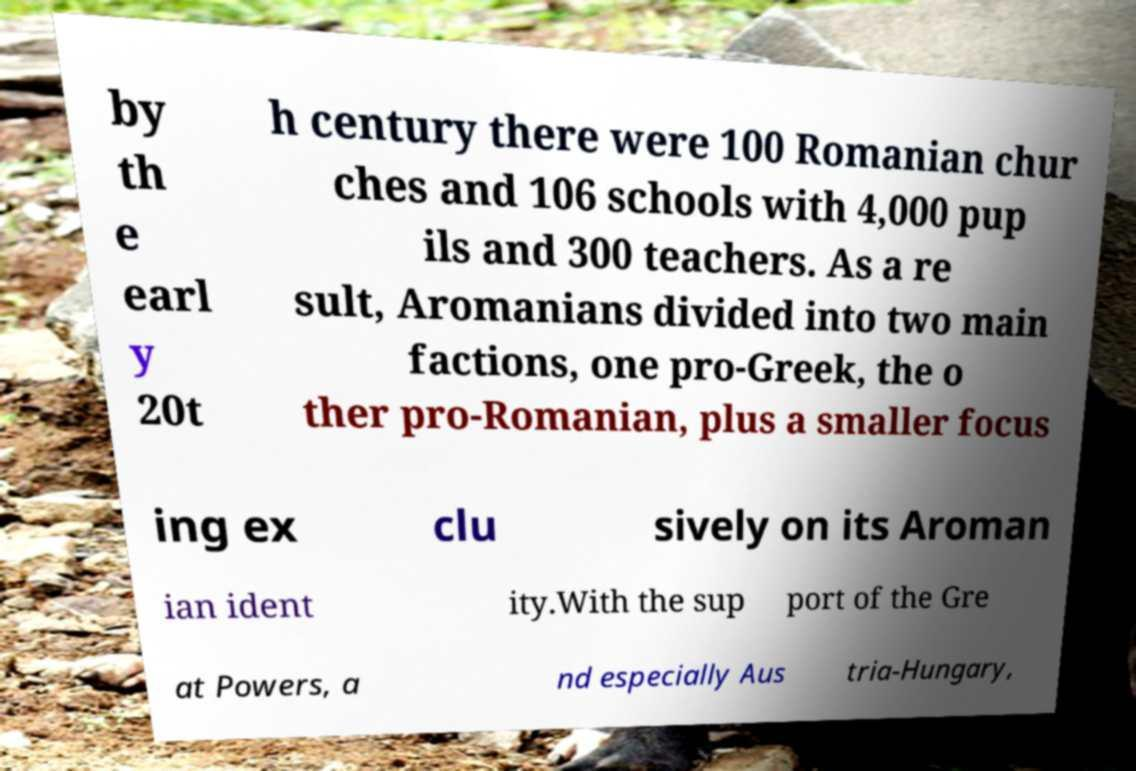There's text embedded in this image that I need extracted. Can you transcribe it verbatim? by th e earl y 20t h century there were 100 Romanian chur ches and 106 schools with 4,000 pup ils and 300 teachers. As a re sult, Aromanians divided into two main factions, one pro-Greek, the o ther pro-Romanian, plus a smaller focus ing ex clu sively on its Aroman ian ident ity.With the sup port of the Gre at Powers, a nd especially Aus tria-Hungary, 